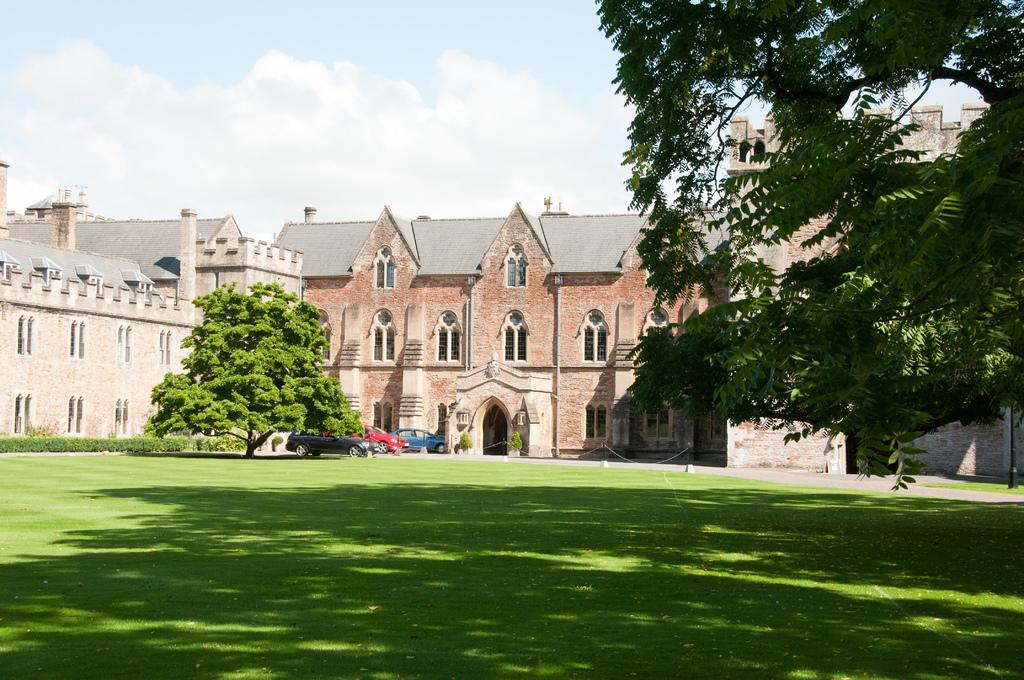How would you summarize this image in a sentence or two? In this image we can see few buildings and there are some trees, plants and grass on the ground. We can see three vehicles and at the top we can see the sky. 